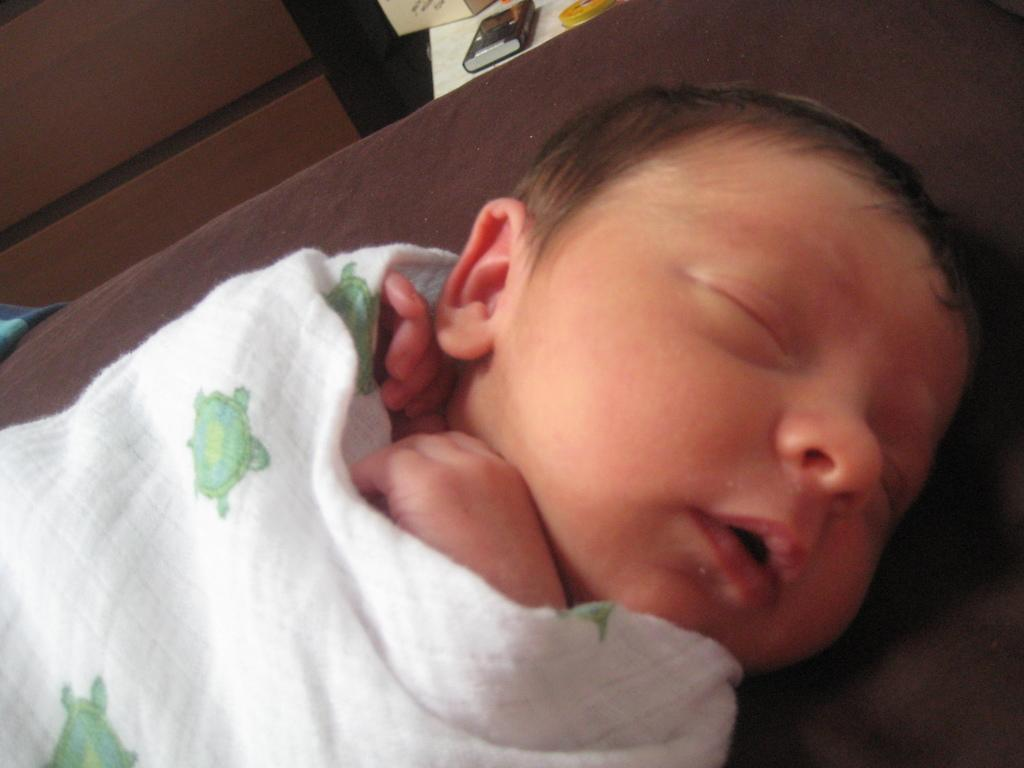What is the main subject of the image? There is a baby in the image. Where is the baby located? The baby is sleeping on a bed. What electronic device is visible in the image? There is a mobile phone at the top of the image. What can be seen on the table in the image? There are two objects on a table in the image. How many cattle are visible in the image? There are no cattle present in the image. What type of bikes are being ridden by the baby in the image? The baby is sleeping on a bed and there are no bikes present in the image. 